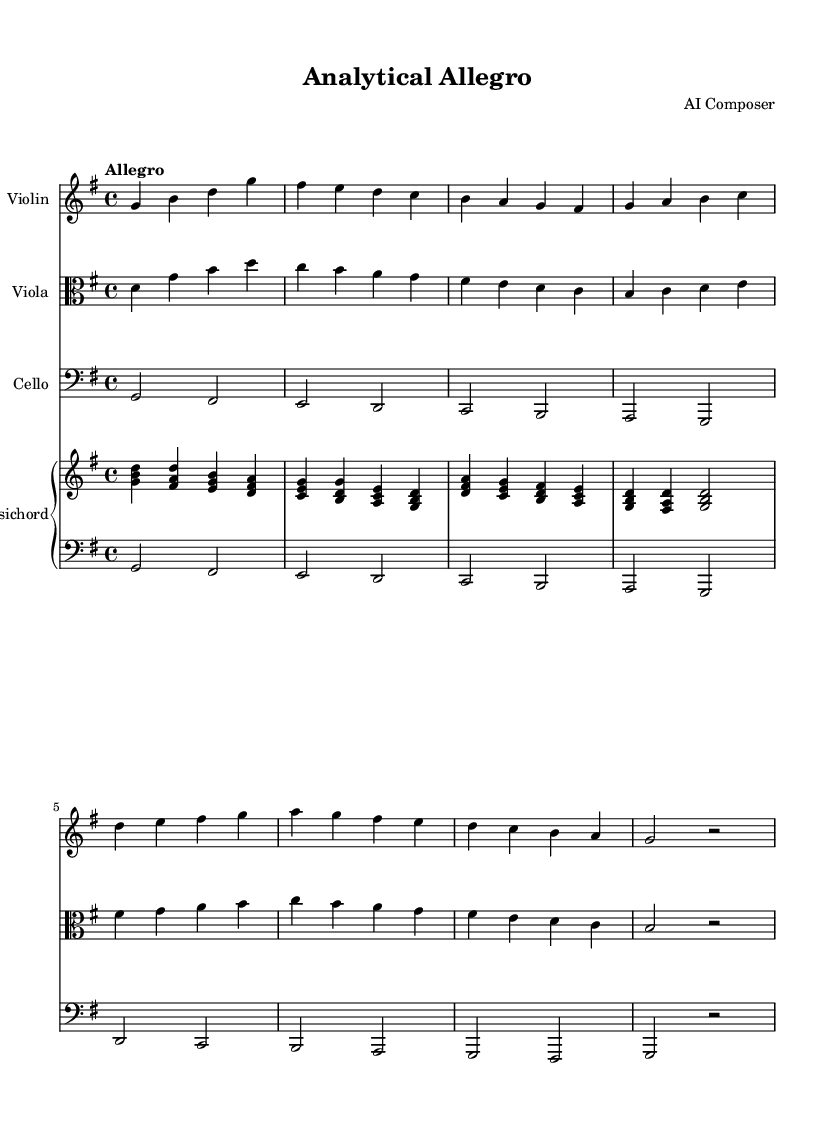What is the key signature of this music? The key signature is G major, which has one sharp (F sharp).
Answer: G major What is the time signature of this music? The time signature is four-four, indicating four beats per measure.
Answer: Four-four What is the tempo marking of this piece? The tempo marking is "Allegro," indicating a fast and lively pace.
Answer: Allegro How many instruments are used in this chamber music piece? There are four instruments: violin, viola, cello, and harpsichord.
Answer: Four Which instrument has the highest pitch range? The violin has the highest pitch range compared to the viola and cello.
Answer: Violin How many measures are in the violin part? The violin part contains eight measures, as indicated by the grouping of notes.
Answer: Eight What is the lowest note played by the cello? The lowest note played by the cello is a D.
Answer: D 